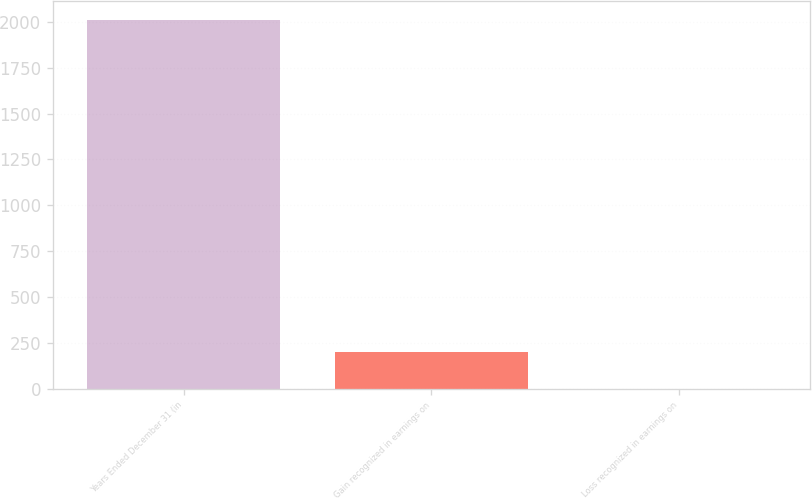Convert chart. <chart><loc_0><loc_0><loc_500><loc_500><bar_chart><fcel>Years Ended December 31 (in<fcel>Gain recognized in earnings on<fcel>Loss recognized in earnings on<nl><fcel>2012<fcel>203<fcel>2<nl></chart> 